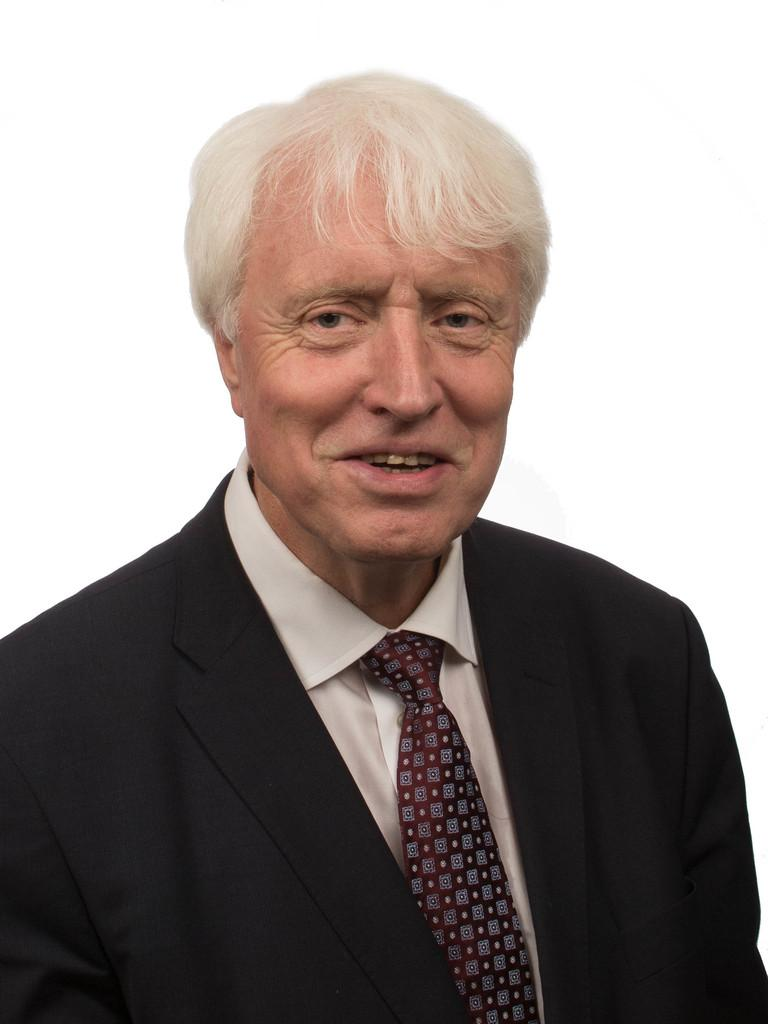What is the main subject of the image? There is a person in the image. What is the person's facial expression? The person is smiling. What type of clothing is the person wearing? The person is wearing a suit. What type of picture is the person holding in the image? There is no picture present in the image; the person is not holding anything. 